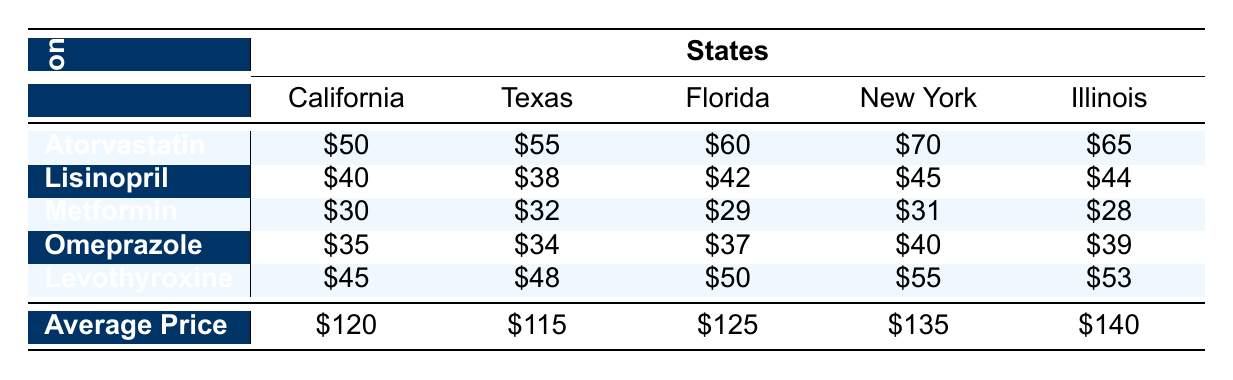What is the average price of prescription drugs in New York? The average price in New York is provided in the last row of the table, which indicates \$135.
Answer: 135 Which state has the lowest price for Lisinopril? Looking at the Lisinopril row, Texas has the lowest price at \$38.
Answer: Texas What is the difference in average price between California and Illinois? The average price in California is \$120 and in Illinois is \$140. The difference is \$140 - \$120 = \$20.
Answer: 20 Is the price of Metformin higher in Florida than in Texas? In Florida, Metformin costs \$29, while in Texas it costs \$32. Since \$29 is less than \$32, the statement is false.
Answer: No What is the total cost of Levothyroxine in California, Texas, and Florida combined? The cost for Levothyroxine in California is \$45, in Texas is \$48, and in Florida is \$50. Summing these amounts gives \$45 + \$48 + \$50 = \$143.
Answer: 143 Which medication is the most expensive in New York? Referring to the New York row, Atorvastatin is priced at \$70, which is higher than Lisinopril (\$45), Metformin (\$31), Omeprazole (\$40), and Levothyroxine (\$55). Therefore, Atorvastatin is the most expensive.
Answer: Atorvastatin Which state has the highest price for Omeprazole? By examining the Omeprazole row, New York has the highest price at \$40.
Answer: New York What is the average price of prescription drugs across all five states? We sum the average prices for each state: \$120 (California) + \$115 (Texas) + \$125 (Florida) + \$135 (New York) + \$140 (Illinois) = \$635. There are five states, so the average is \$635 / 5 = \$127.
Answer: 127 Which medication is cheaper: Metformin in Illinois or Lisinopril in Florida? Metformin costs \$28 in Illinois and Lisinopril costs \$42 in Florida. Since \$28 is less than \$42, Metformin is cheaper.
Answer: Metformin 